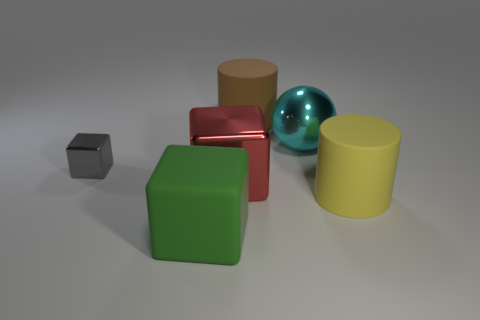Add 1 large brown matte cylinders. How many objects exist? 7 Subtract all cylinders. How many objects are left? 4 Add 3 yellow rubber cylinders. How many yellow rubber cylinders are left? 4 Add 1 big purple matte balls. How many big purple matte balls exist? 1 Subtract 0 yellow cubes. How many objects are left? 6 Subtract all tiny brown cylinders. Subtract all large yellow matte objects. How many objects are left? 5 